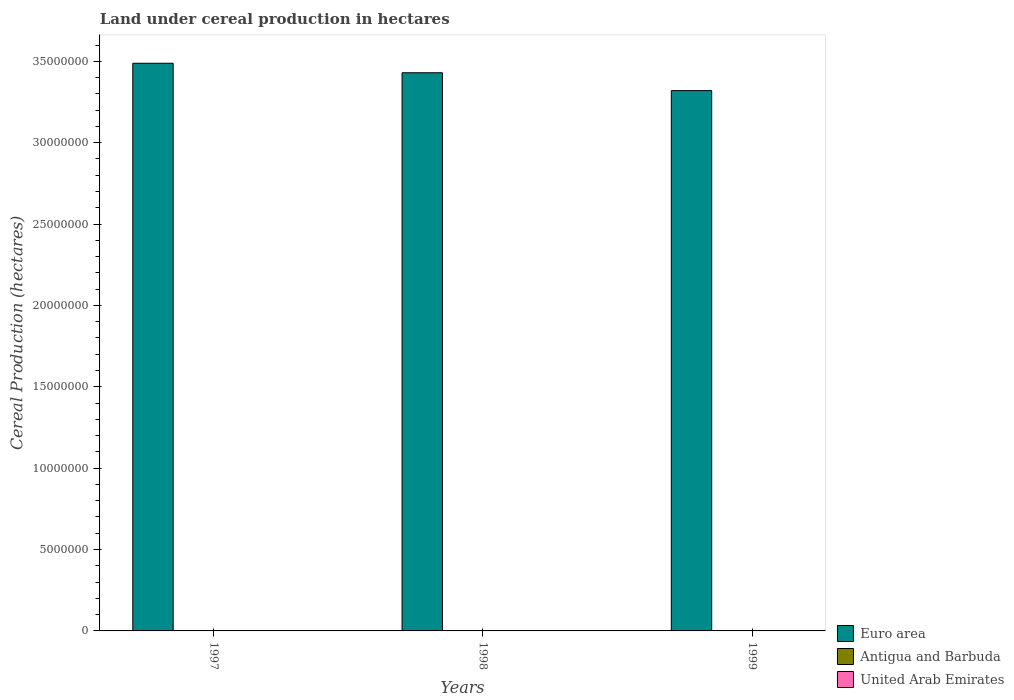How many groups of bars are there?
Provide a short and direct response. 3. Are the number of bars per tick equal to the number of legend labels?
Your answer should be very brief. Yes. Are the number of bars on each tick of the X-axis equal?
Keep it short and to the point. Yes. How many bars are there on the 2nd tick from the left?
Offer a very short reply. 3. How many bars are there on the 2nd tick from the right?
Provide a short and direct response. 3. What is the label of the 2nd group of bars from the left?
Keep it short and to the point. 1998. What is the land under cereal production in Euro area in 1998?
Your answer should be very brief. 3.43e+07. In which year was the land under cereal production in United Arab Emirates minimum?
Your answer should be very brief. 1998. What is the total land under cereal production in Euro area in the graph?
Your answer should be compact. 1.02e+08. What is the difference between the land under cereal production in Antigua and Barbuda in 1997 and that in 1998?
Your answer should be very brief. 5. What is the difference between the land under cereal production in Antigua and Barbuda in 1997 and the land under cereal production in Euro area in 1999?
Your response must be concise. -3.32e+07. What is the average land under cereal production in United Arab Emirates per year?
Your response must be concise. 53. In the year 1999, what is the difference between the land under cereal production in Euro area and land under cereal production in Antigua and Barbuda?
Offer a terse response. 3.32e+07. In how many years, is the land under cereal production in Antigua and Barbuda greater than 32000000 hectares?
Give a very brief answer. 0. What is the ratio of the land under cereal production in Euro area in 1998 to that in 1999?
Make the answer very short. 1.03. Is the land under cereal production in United Arab Emirates in 1998 less than that in 1999?
Offer a terse response. Yes. Is the difference between the land under cereal production in Euro area in 1998 and 1999 greater than the difference between the land under cereal production in Antigua and Barbuda in 1998 and 1999?
Give a very brief answer. Yes. What is the difference between the highest and the second highest land under cereal production in Euro area?
Your answer should be compact. 5.83e+05. What is the difference between the highest and the lowest land under cereal production in Euro area?
Ensure brevity in your answer.  1.68e+06. What does the 2nd bar from the left in 1999 represents?
Provide a short and direct response. Antigua and Barbuda. Is it the case that in every year, the sum of the land under cereal production in Euro area and land under cereal production in Antigua and Barbuda is greater than the land under cereal production in United Arab Emirates?
Your answer should be very brief. Yes. How many years are there in the graph?
Give a very brief answer. 3. What is the difference between two consecutive major ticks on the Y-axis?
Keep it short and to the point. 5.00e+06. Does the graph contain grids?
Give a very brief answer. No. Where does the legend appear in the graph?
Offer a very short reply. Bottom right. How many legend labels are there?
Ensure brevity in your answer.  3. How are the legend labels stacked?
Your response must be concise. Vertical. What is the title of the graph?
Offer a terse response. Land under cereal production in hectares. What is the label or title of the X-axis?
Provide a short and direct response. Years. What is the label or title of the Y-axis?
Ensure brevity in your answer.  Cereal Production (hectares). What is the Cereal Production (hectares) in Euro area in 1997?
Make the answer very short. 3.49e+07. What is the Cereal Production (hectares) of Antigua and Barbuda in 1997?
Offer a terse response. 39. What is the Cereal Production (hectares) in United Arab Emirates in 1997?
Keep it short and to the point. 58. What is the Cereal Production (hectares) of Euro area in 1998?
Your answer should be very brief. 3.43e+07. What is the Cereal Production (hectares) in Antigua and Barbuda in 1998?
Make the answer very short. 34. What is the Cereal Production (hectares) of United Arab Emirates in 1998?
Your answer should be compact. 50. What is the Cereal Production (hectares) of Euro area in 1999?
Your answer should be very brief. 3.32e+07. What is the Cereal Production (hectares) of United Arab Emirates in 1999?
Provide a succinct answer. 51. Across all years, what is the maximum Cereal Production (hectares) in Euro area?
Provide a succinct answer. 3.49e+07. Across all years, what is the maximum Cereal Production (hectares) of Antigua and Barbuda?
Keep it short and to the point. 39. Across all years, what is the minimum Cereal Production (hectares) of Euro area?
Provide a short and direct response. 3.32e+07. What is the total Cereal Production (hectares) of Euro area in the graph?
Ensure brevity in your answer.  1.02e+08. What is the total Cereal Production (hectares) of Antigua and Barbuda in the graph?
Your response must be concise. 102. What is the total Cereal Production (hectares) of United Arab Emirates in the graph?
Provide a short and direct response. 159. What is the difference between the Cereal Production (hectares) of Euro area in 1997 and that in 1998?
Your response must be concise. 5.83e+05. What is the difference between the Cereal Production (hectares) in Antigua and Barbuda in 1997 and that in 1998?
Your answer should be very brief. 5. What is the difference between the Cereal Production (hectares) in Euro area in 1997 and that in 1999?
Your response must be concise. 1.68e+06. What is the difference between the Cereal Production (hectares) in Antigua and Barbuda in 1997 and that in 1999?
Your answer should be very brief. 10. What is the difference between the Cereal Production (hectares) of United Arab Emirates in 1997 and that in 1999?
Ensure brevity in your answer.  7. What is the difference between the Cereal Production (hectares) in Euro area in 1998 and that in 1999?
Your answer should be compact. 1.10e+06. What is the difference between the Cereal Production (hectares) in Euro area in 1997 and the Cereal Production (hectares) in Antigua and Barbuda in 1998?
Provide a short and direct response. 3.49e+07. What is the difference between the Cereal Production (hectares) of Euro area in 1997 and the Cereal Production (hectares) of United Arab Emirates in 1998?
Ensure brevity in your answer.  3.49e+07. What is the difference between the Cereal Production (hectares) in Euro area in 1997 and the Cereal Production (hectares) in Antigua and Barbuda in 1999?
Keep it short and to the point. 3.49e+07. What is the difference between the Cereal Production (hectares) of Euro area in 1997 and the Cereal Production (hectares) of United Arab Emirates in 1999?
Give a very brief answer. 3.49e+07. What is the difference between the Cereal Production (hectares) in Euro area in 1998 and the Cereal Production (hectares) in Antigua and Barbuda in 1999?
Keep it short and to the point. 3.43e+07. What is the difference between the Cereal Production (hectares) in Euro area in 1998 and the Cereal Production (hectares) in United Arab Emirates in 1999?
Offer a very short reply. 3.43e+07. What is the difference between the Cereal Production (hectares) of Antigua and Barbuda in 1998 and the Cereal Production (hectares) of United Arab Emirates in 1999?
Provide a short and direct response. -17. What is the average Cereal Production (hectares) in Euro area per year?
Ensure brevity in your answer.  3.41e+07. What is the average Cereal Production (hectares) in Antigua and Barbuda per year?
Your answer should be compact. 34. In the year 1997, what is the difference between the Cereal Production (hectares) of Euro area and Cereal Production (hectares) of Antigua and Barbuda?
Provide a short and direct response. 3.49e+07. In the year 1997, what is the difference between the Cereal Production (hectares) in Euro area and Cereal Production (hectares) in United Arab Emirates?
Provide a succinct answer. 3.49e+07. In the year 1997, what is the difference between the Cereal Production (hectares) in Antigua and Barbuda and Cereal Production (hectares) in United Arab Emirates?
Provide a short and direct response. -19. In the year 1998, what is the difference between the Cereal Production (hectares) in Euro area and Cereal Production (hectares) in Antigua and Barbuda?
Provide a succinct answer. 3.43e+07. In the year 1998, what is the difference between the Cereal Production (hectares) of Euro area and Cereal Production (hectares) of United Arab Emirates?
Provide a short and direct response. 3.43e+07. In the year 1999, what is the difference between the Cereal Production (hectares) in Euro area and Cereal Production (hectares) in Antigua and Barbuda?
Offer a terse response. 3.32e+07. In the year 1999, what is the difference between the Cereal Production (hectares) of Euro area and Cereal Production (hectares) of United Arab Emirates?
Your response must be concise. 3.32e+07. What is the ratio of the Cereal Production (hectares) of Antigua and Barbuda in 1997 to that in 1998?
Your answer should be compact. 1.15. What is the ratio of the Cereal Production (hectares) of United Arab Emirates in 1997 to that in 1998?
Your answer should be compact. 1.16. What is the ratio of the Cereal Production (hectares) of Euro area in 1997 to that in 1999?
Your response must be concise. 1.05. What is the ratio of the Cereal Production (hectares) of Antigua and Barbuda in 1997 to that in 1999?
Keep it short and to the point. 1.34. What is the ratio of the Cereal Production (hectares) in United Arab Emirates in 1997 to that in 1999?
Provide a short and direct response. 1.14. What is the ratio of the Cereal Production (hectares) of Euro area in 1998 to that in 1999?
Your answer should be compact. 1.03. What is the ratio of the Cereal Production (hectares) of Antigua and Barbuda in 1998 to that in 1999?
Offer a terse response. 1.17. What is the ratio of the Cereal Production (hectares) of United Arab Emirates in 1998 to that in 1999?
Ensure brevity in your answer.  0.98. What is the difference between the highest and the second highest Cereal Production (hectares) of Euro area?
Your answer should be very brief. 5.83e+05. What is the difference between the highest and the lowest Cereal Production (hectares) in Euro area?
Make the answer very short. 1.68e+06. 